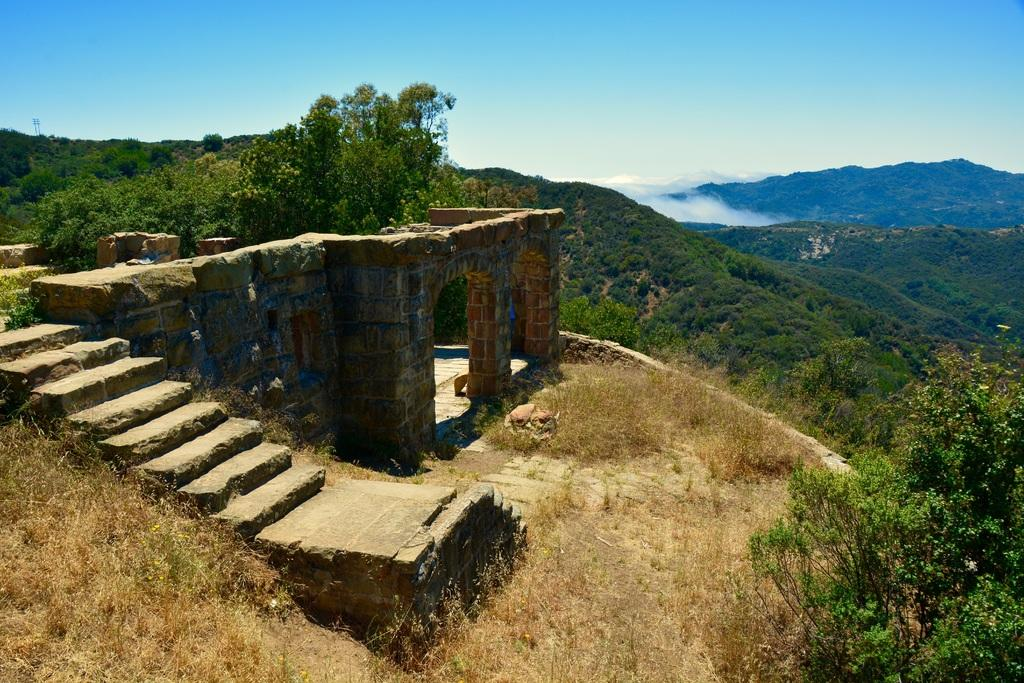What type of structure can be seen in the image? There is a wall in the image. What architectural feature is present in the image? There are stairs in the image. What type of vegetation is visible in the image? There are plants and trees in the image. What type of landscape can be seen in the image? There are hills in the image. What part of the natural environment is visible in the image? The sky and ground are visible in the image. What type of ground cover is present in the image? There is grass in the image. How many planes are flying over the hills in the image? There are no planes visible in the image; it only features a wall, stairs, plants, trees, hills, sky, ground, and grass. 